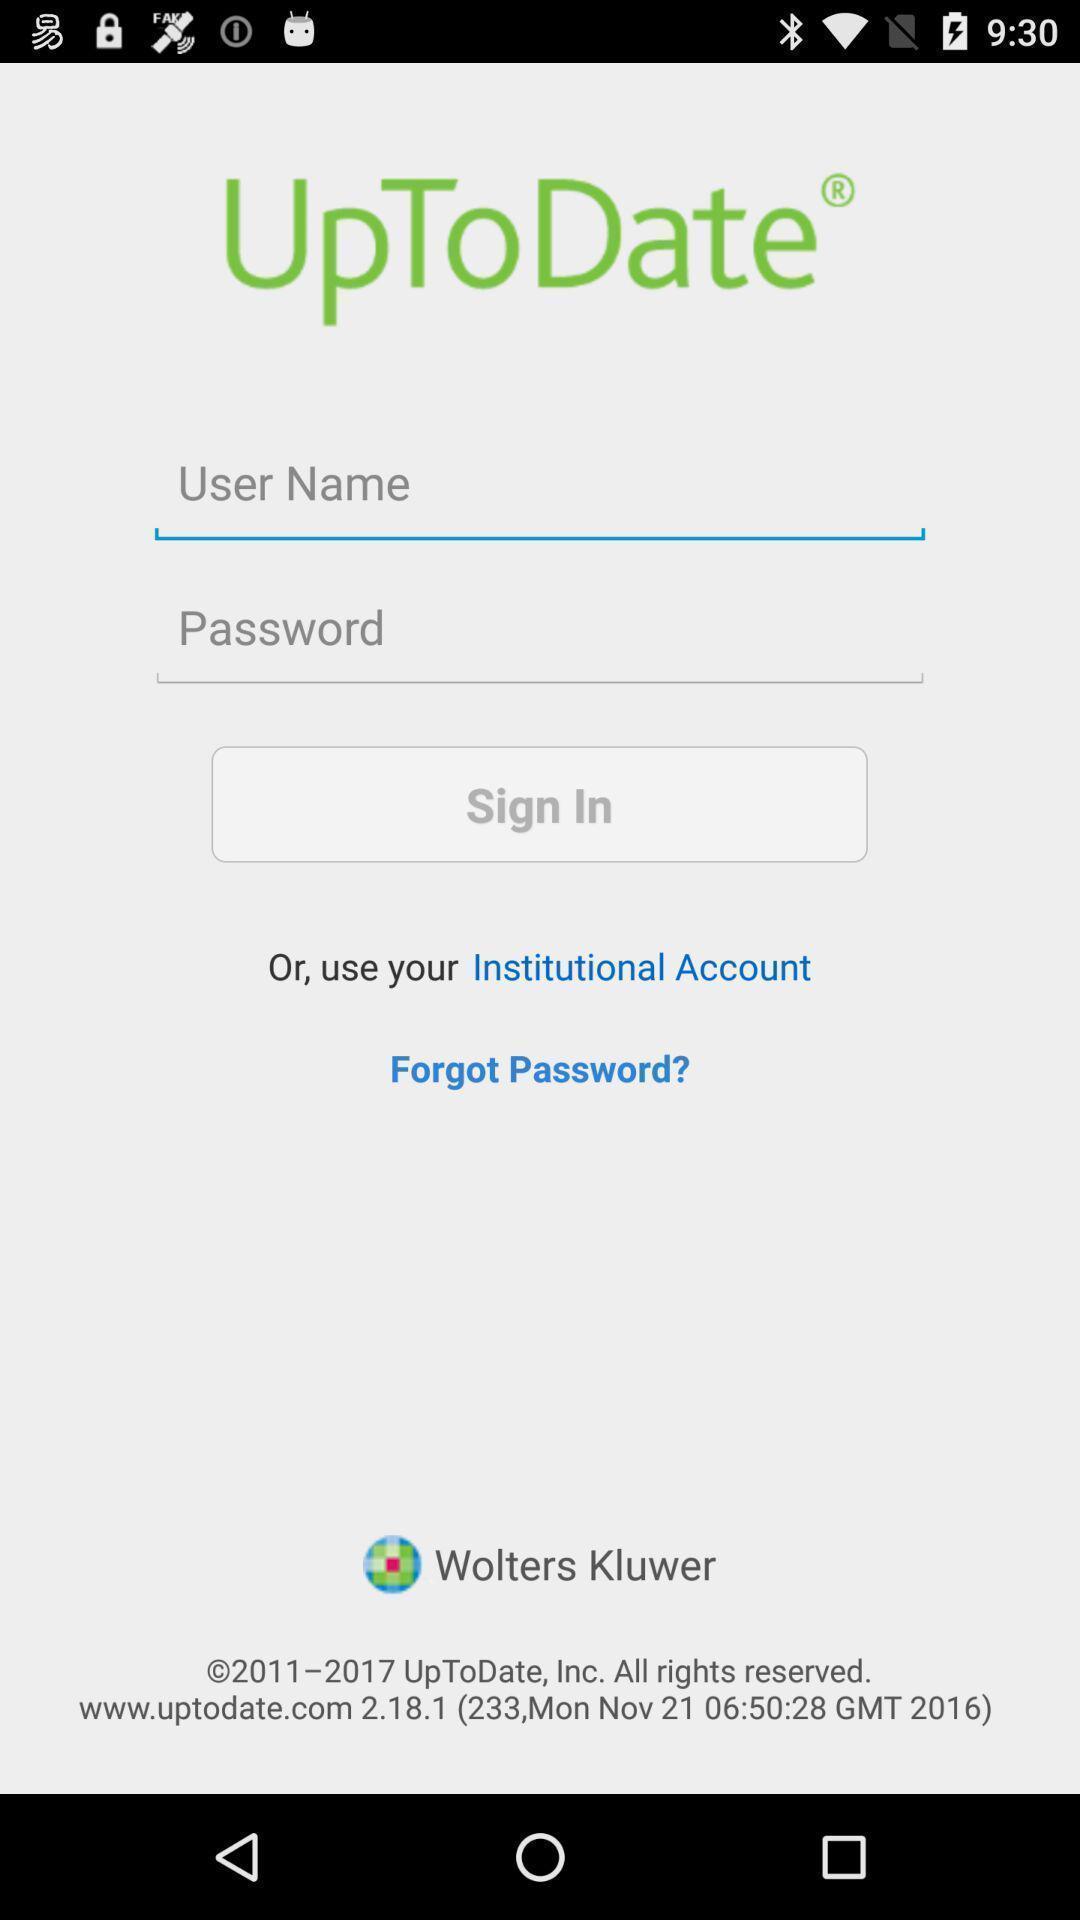Give me a narrative description of this picture. Sign-in page. 